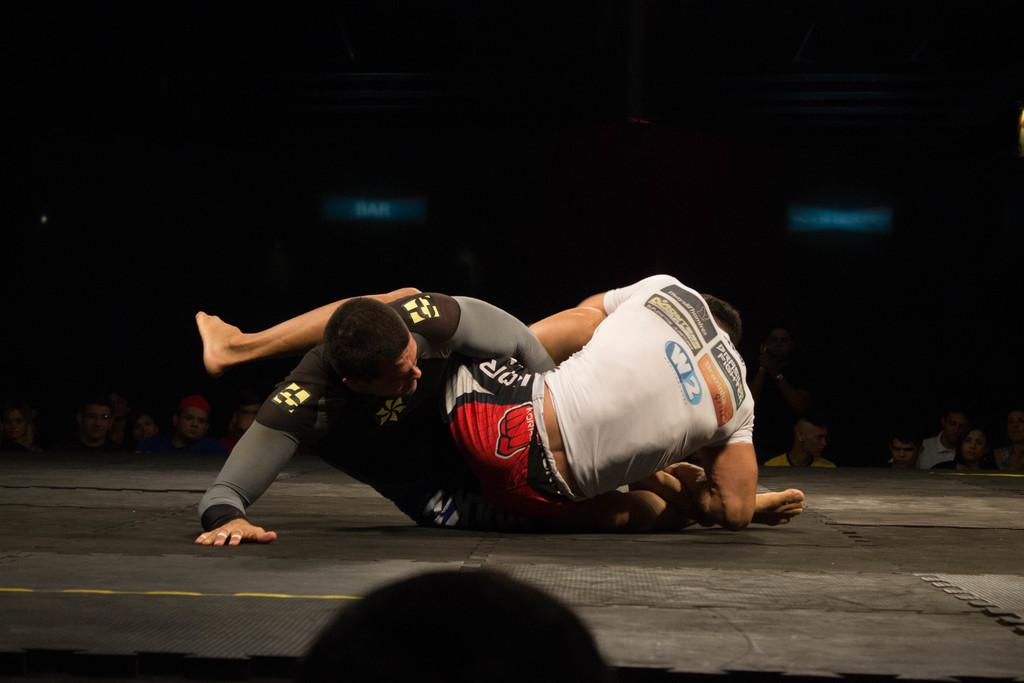How many people are in the image? There are two men in the image. What are the two men doing in the image? The two men are wrestling. Can you describe the clothing of the man wearing the lighter-colored t-shirt? The man wearing the lighter-colored t-shirt is wearing a white t-shirt. Can you describe the clothing of the man wearing the darker-colored t-shirt? The man wearing the darker-colored t-shirt is wearing a black t-shirt. What type of fold can be seen in the man's t-shirt in the image? There is no fold visible in the men's t-shirts in the image. Can you describe the carriage that the men are using to wrestle in the image? There is no carriage present in the image; the men are wrestling on a surface that is not visible. 